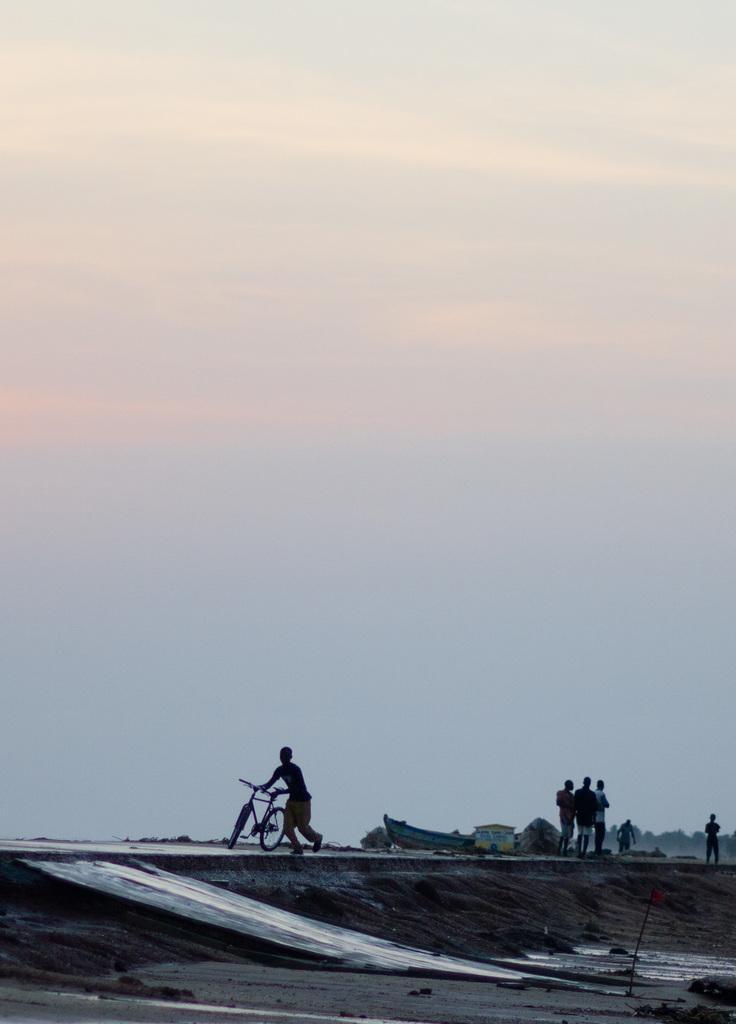How would you summarize this image in a sentence or two? There are people and this person walking and holding bicycle. We can see boat and house. In the background we can see trees and sky. 